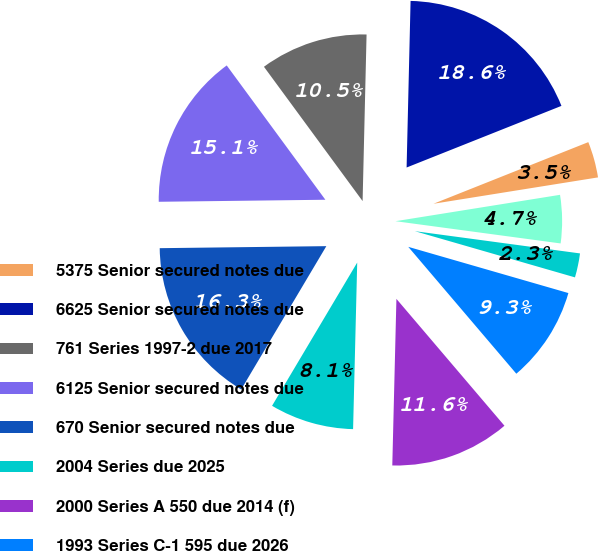Convert chart to OTSL. <chart><loc_0><loc_0><loc_500><loc_500><pie_chart><fcel>5375 Senior secured notes due<fcel>6625 Senior secured notes due<fcel>761 Series 1997-2 due 2017<fcel>6125 Senior secured notes due<fcel>670 Senior secured notes due<fcel>2004 Series due 2025<fcel>2000 Series A 550 due 2014 (f)<fcel>1993 Series C-1 595 due 2026<fcel>1993 Series C-2 570 due 2026<fcel>1993 Series B-1 due 2028 (d)<nl><fcel>3.5%<fcel>18.59%<fcel>10.46%<fcel>15.11%<fcel>16.27%<fcel>8.14%<fcel>11.62%<fcel>9.3%<fcel>2.34%<fcel>4.66%<nl></chart> 